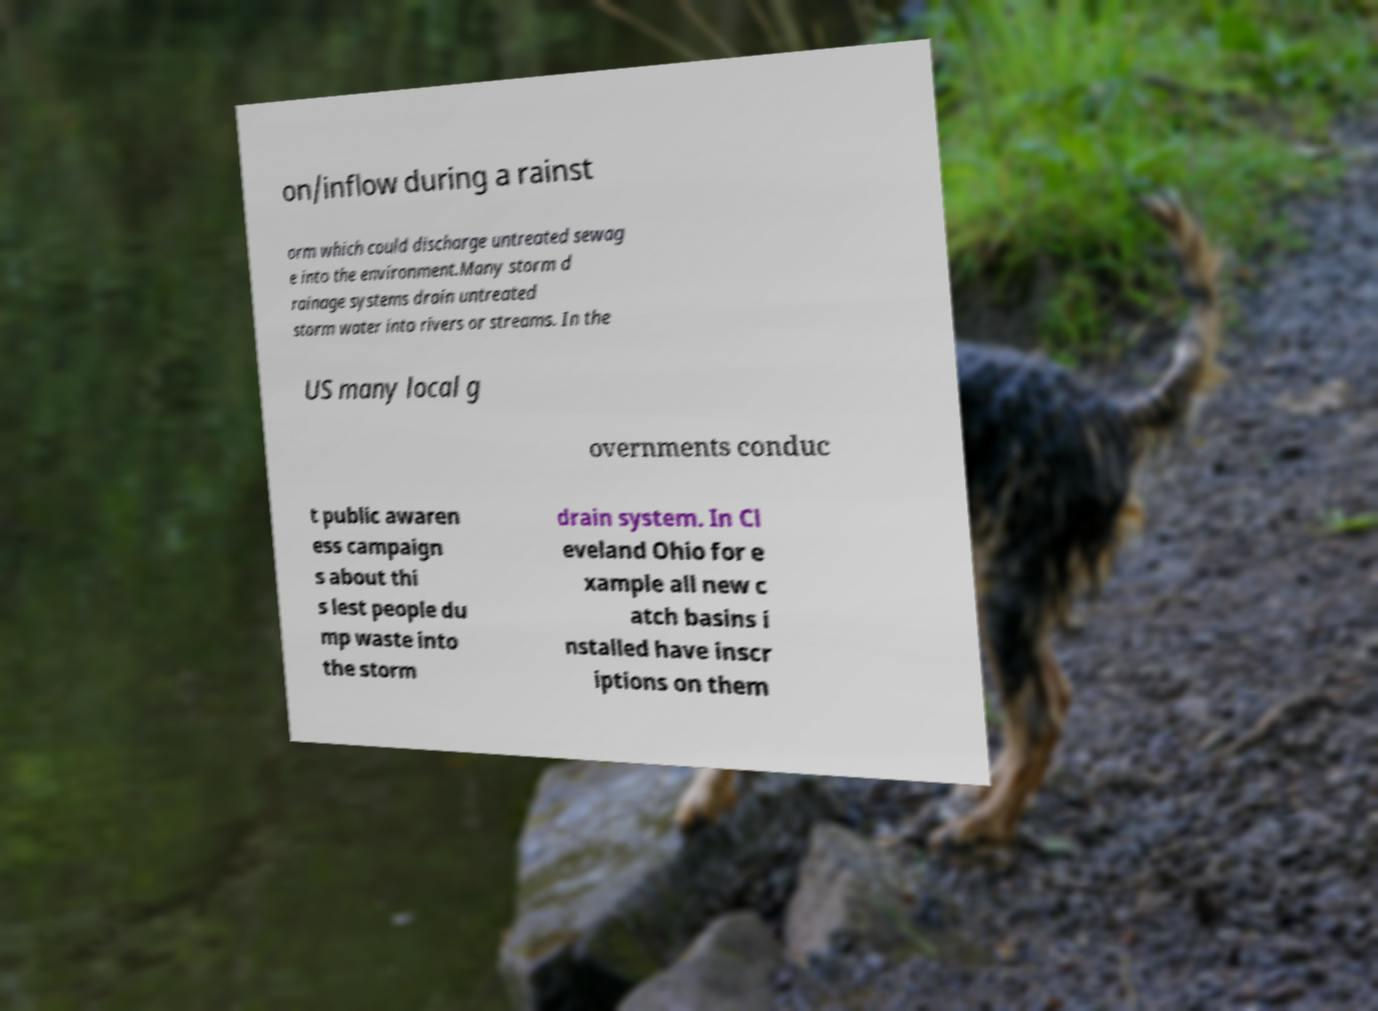Can you read and provide the text displayed in the image?This photo seems to have some interesting text. Can you extract and type it out for me? on/inflow during a rainst orm which could discharge untreated sewag e into the environment.Many storm d rainage systems drain untreated storm water into rivers or streams. In the US many local g overnments conduc t public awaren ess campaign s about thi s lest people du mp waste into the storm drain system. In Cl eveland Ohio for e xample all new c atch basins i nstalled have inscr iptions on them 